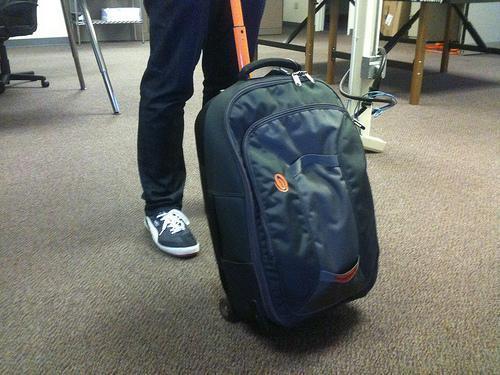How many people are holding luggages?
Give a very brief answer. 1. 